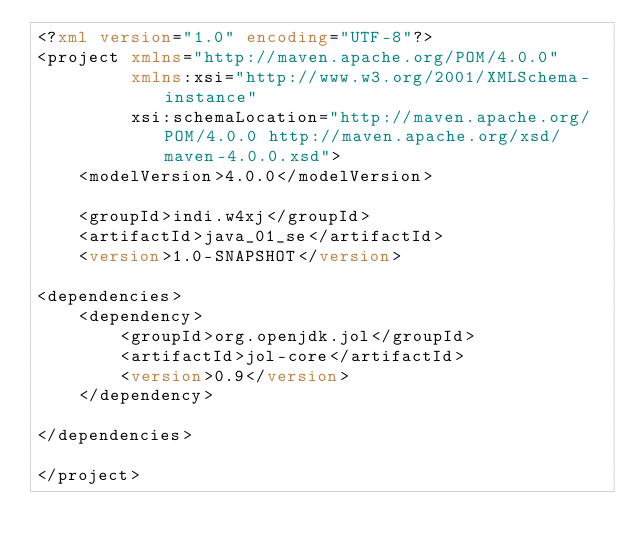<code> <loc_0><loc_0><loc_500><loc_500><_XML_><?xml version="1.0" encoding="UTF-8"?>
<project xmlns="http://maven.apache.org/POM/4.0.0"
         xmlns:xsi="http://www.w3.org/2001/XMLSchema-instance"
         xsi:schemaLocation="http://maven.apache.org/POM/4.0.0 http://maven.apache.org/xsd/maven-4.0.0.xsd">
    <modelVersion>4.0.0</modelVersion>

    <groupId>indi.w4xj</groupId>
    <artifactId>java_01_se</artifactId>
    <version>1.0-SNAPSHOT</version>

<dependencies>
    <dependency>
        <groupId>org.openjdk.jol</groupId>
        <artifactId>jol-core</artifactId>
        <version>0.9</version>
    </dependency>

</dependencies>

</project></code> 